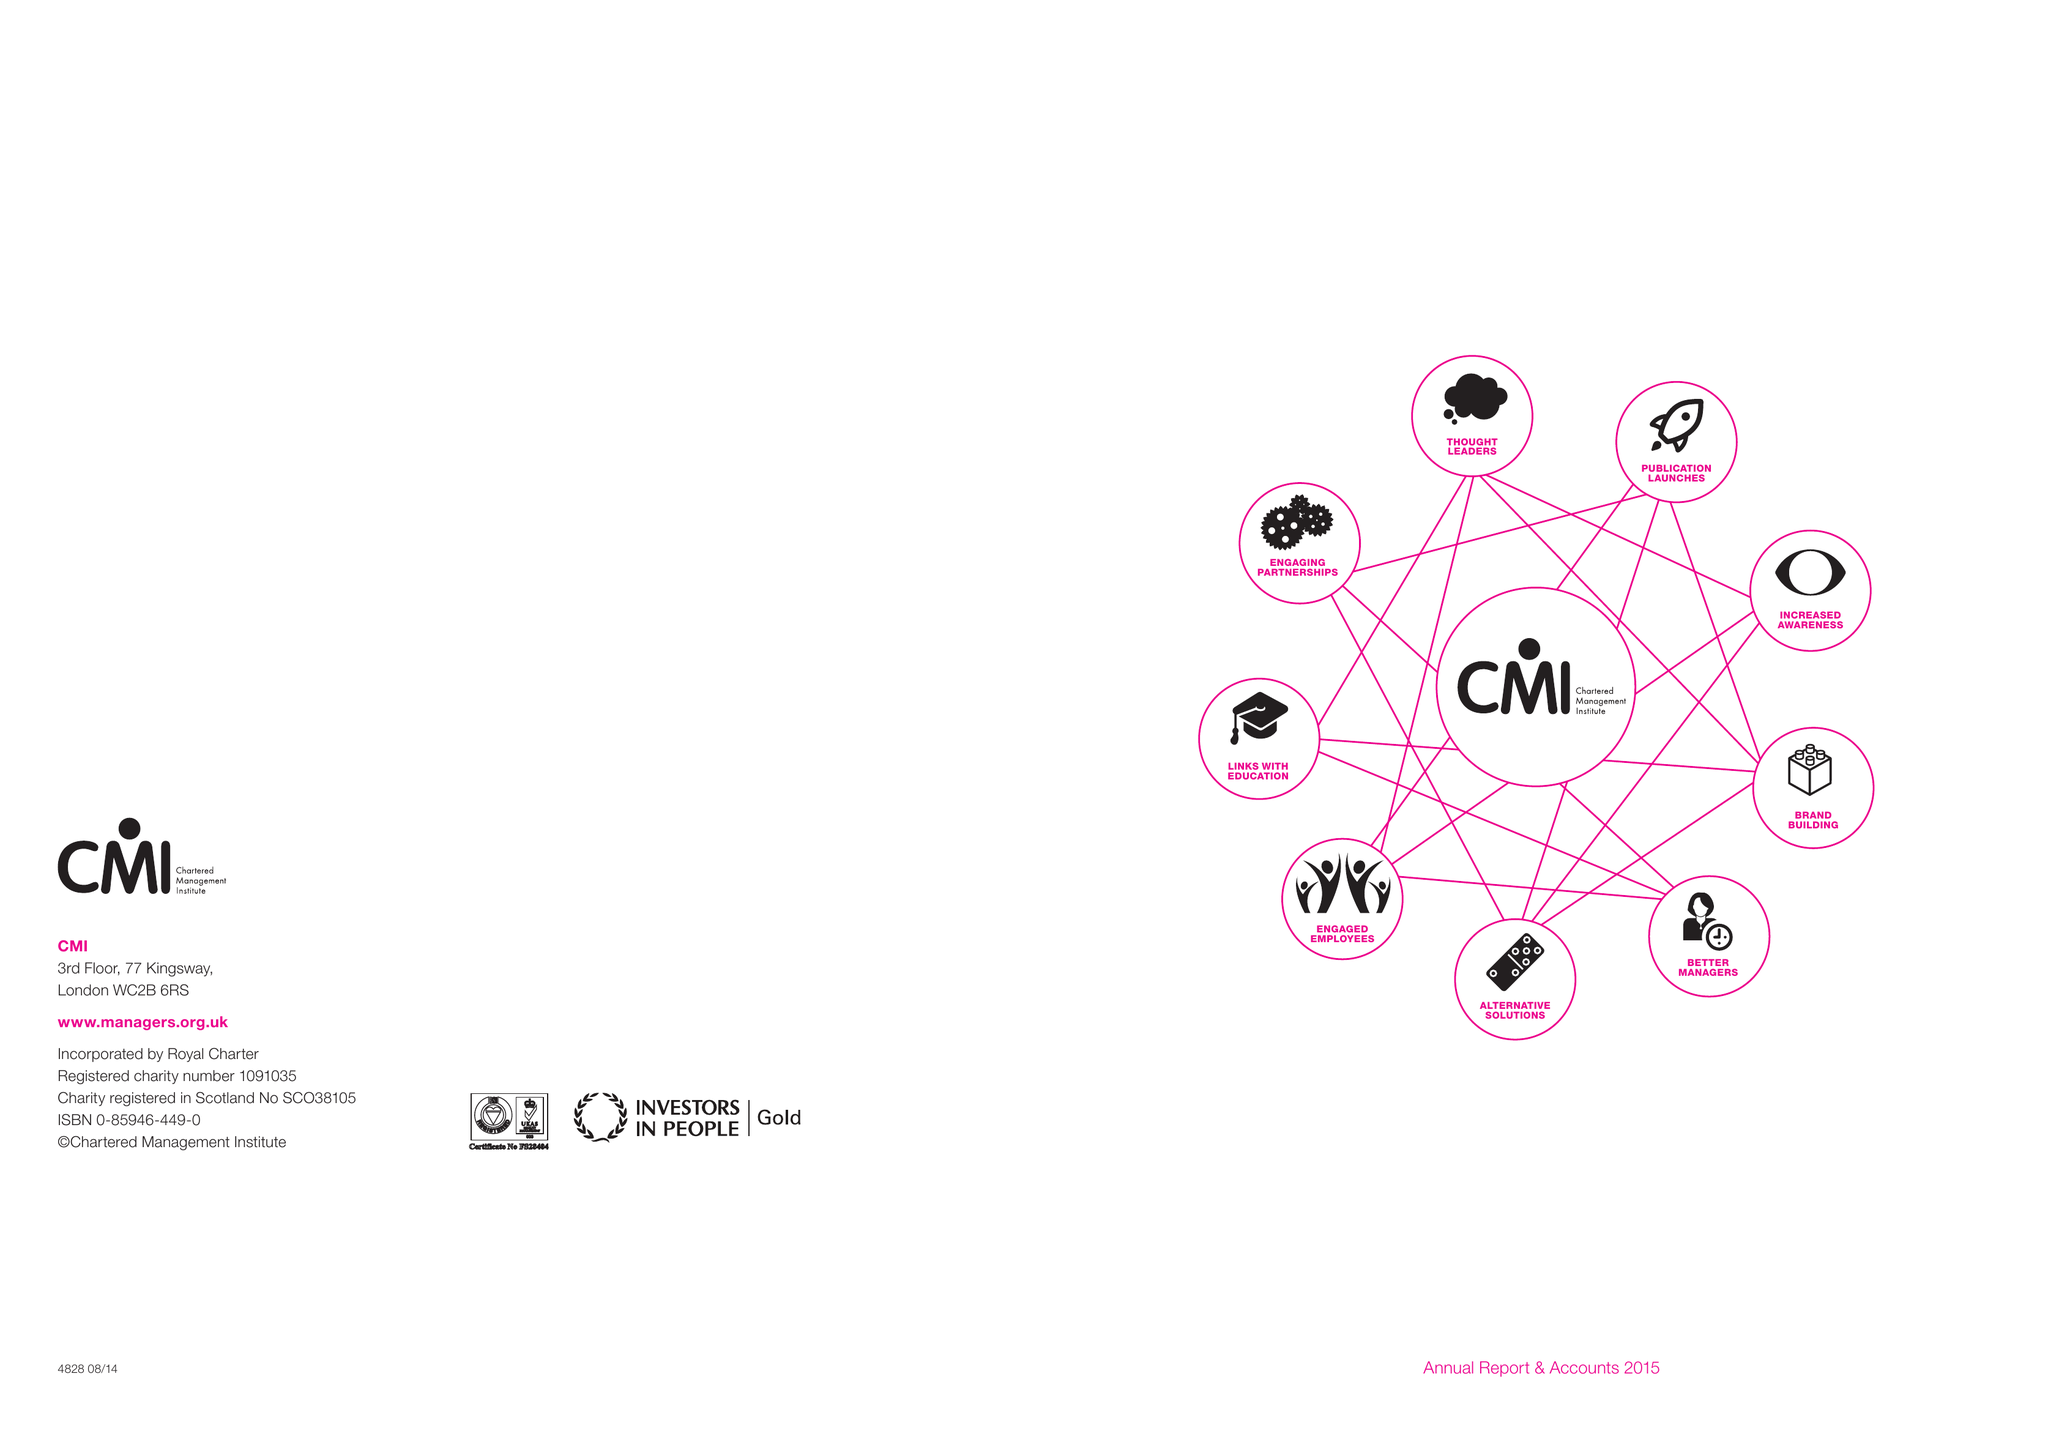What is the value for the income_annually_in_british_pounds?
Answer the question using a single word or phrase. 11680000.00 